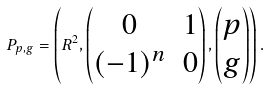Convert formula to latex. <formula><loc_0><loc_0><loc_500><loc_500>P _ { p , g } = \left ( R ^ { 2 } , \begin{pmatrix} 0 & 1 \\ ( - 1 ) ^ { n } & 0 \end{pmatrix} , \begin{pmatrix} p \\ g \end{pmatrix} \right ) .</formula> 